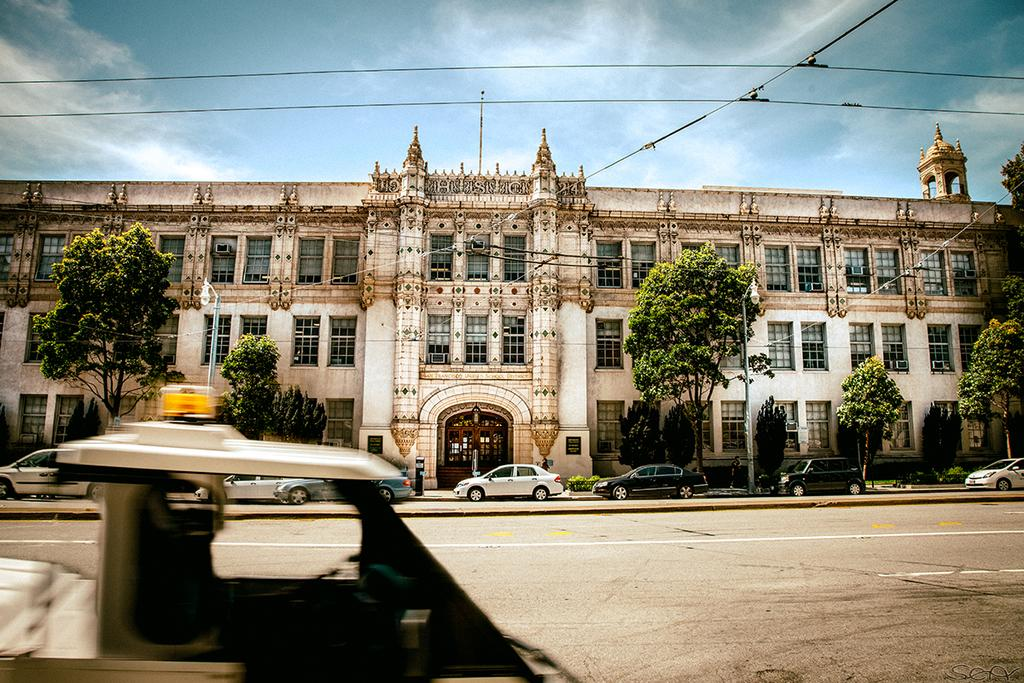What is the main feature of the image? There is a road in the image. What is happening on the road? There are vehicles on the road. What can be seen in the background of the image? There is a building with windows and the sky with clouds is visible in the background. What else is present along the road? There are street light poles in the image. What is the chance of seeing a bike in the image? There is no mention of bikes in the image, so it's impossible to determine the chance of seeing one. What grade does the building in the background receive for its architectural design? The image does not provide any information about the building's architectural design or a grading system, so it's impossible to answer this question. 